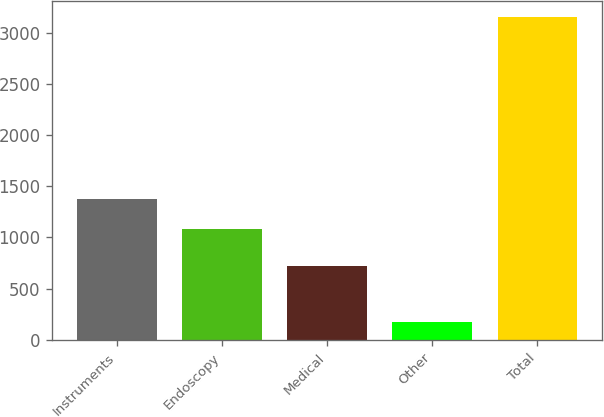<chart> <loc_0><loc_0><loc_500><loc_500><bar_chart><fcel>Instruments<fcel>Endoscopy<fcel>Medical<fcel>Other<fcel>Total<nl><fcel>1378.9<fcel>1080<fcel>722<fcel>171<fcel>3160<nl></chart> 